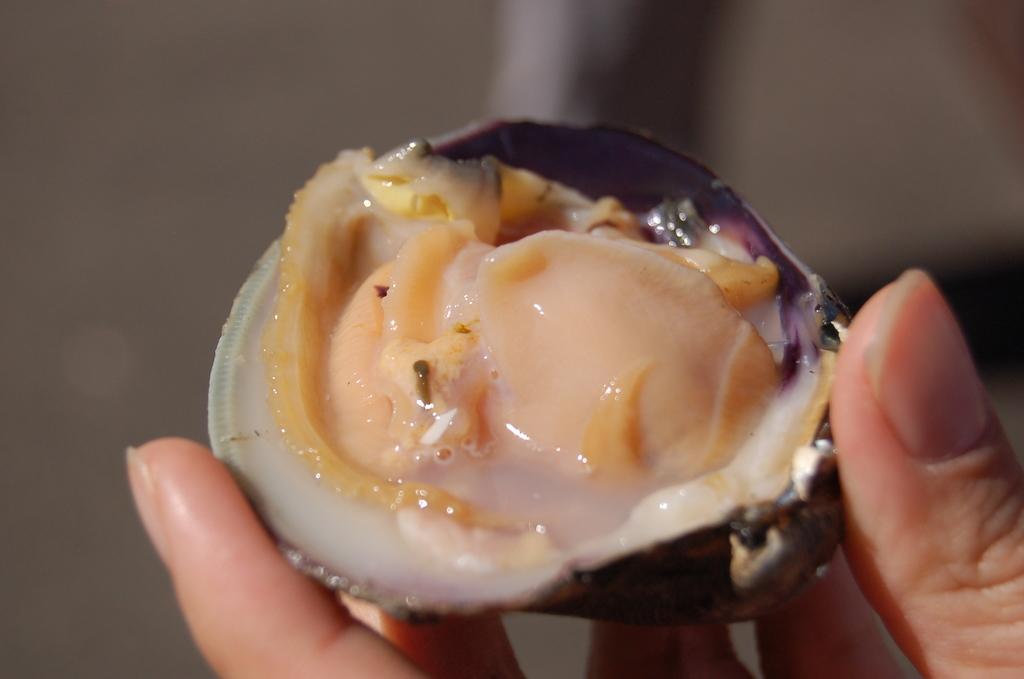Please provide a concise description of this image. On the right side of this image I can see a person's hand holding an oyster. The background is blurred. 